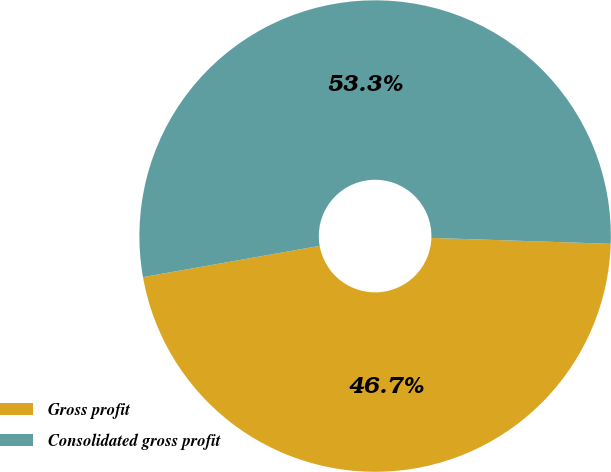<chart> <loc_0><loc_0><loc_500><loc_500><pie_chart><fcel>Gross profit<fcel>Consolidated gross profit<nl><fcel>46.69%<fcel>53.31%<nl></chart> 